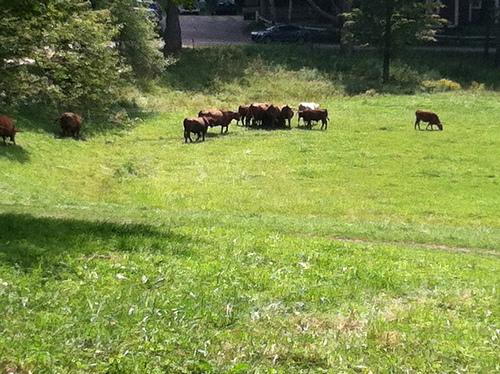List the colors of the cows in the image. The cows in the image are primarily brown. Provide a general description of the scene in the image. The image shows a group of brown cows grazing in a field with short yellow and green grass, and a silverblue sedan parked nearby. Comment on the color and height of the grass in the image. The grass in the image is short and has a mix of yellow and green colors. In the context of the image, what are the main objects interacting with each other? The main objects interacting with each other are the brown cows grazing on the yellowgreen grass. Identify the primary activity taking place in the image. Cows grazing in a green grassy field. Determine the sentiment conveyed by the image. The image conveys a peaceful and calm sentiment with cows grazing in a beautiful natural setting. What kind of vehicle is shown in the picture and where is it positioned? A silverblue four door sedan is parked behind the field. 